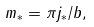Convert formula to latex. <formula><loc_0><loc_0><loc_500><loc_500>m _ { \ast } = \pi j _ { \ast } / b ,</formula> 